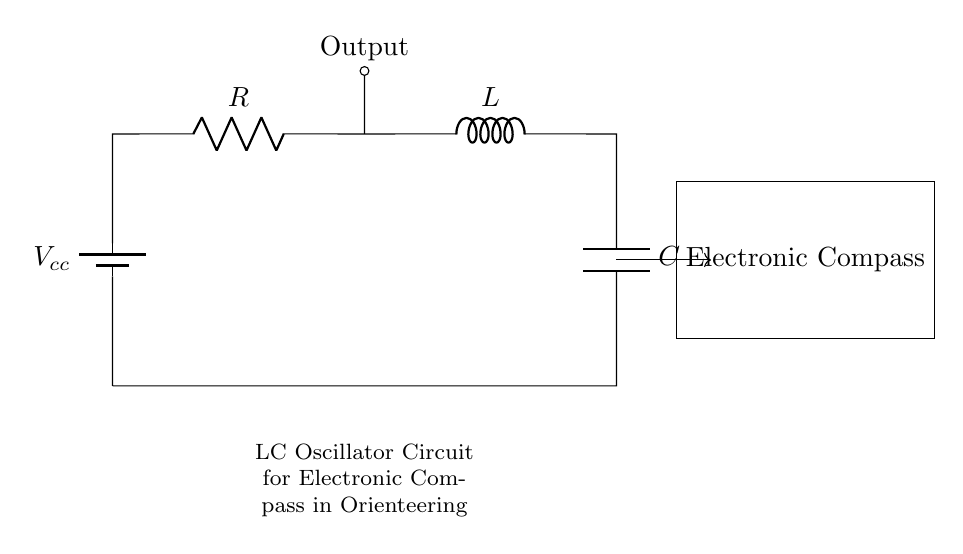What is the total voltage supplied in this circuit? The total voltage supplied is indicated as Vcc in the circuit diagram, which is typically the battery voltage.
Answer: Vcc What components are used in this circuit? The circuit contains three essential components: a resistor, an inductor, and a capacitor, which are shown sequentially in the diagram.
Answer: Resistor, Inductor, Capacitor What type of circuit is illustrated here? This is an LC oscillator circuit, which is specifically designed to generate oscillations using the inductor and capacitor in conjunction with the resistor.
Answer: LC oscillator How does the output relate to the input components? The output is taken from the junction between the resistor and the inductor, indicating that it is influenced by both components' activity in the circuit.
Answer: Influenced by resistor and inductor What role does the inductor play in this circuit? The inductor stores energy in a magnetic field when current passes through it, contributing to the oscillatory behavior characteristic of LC circuits.
Answer: Stores energy in magnetic field How would you describe the purpose of this circuit in an electronic compass? The circuit generates oscillating signals, which are essential for determining direction based on magnetic fields, vital for compass functionality.
Answer: Generates oscillating signals 